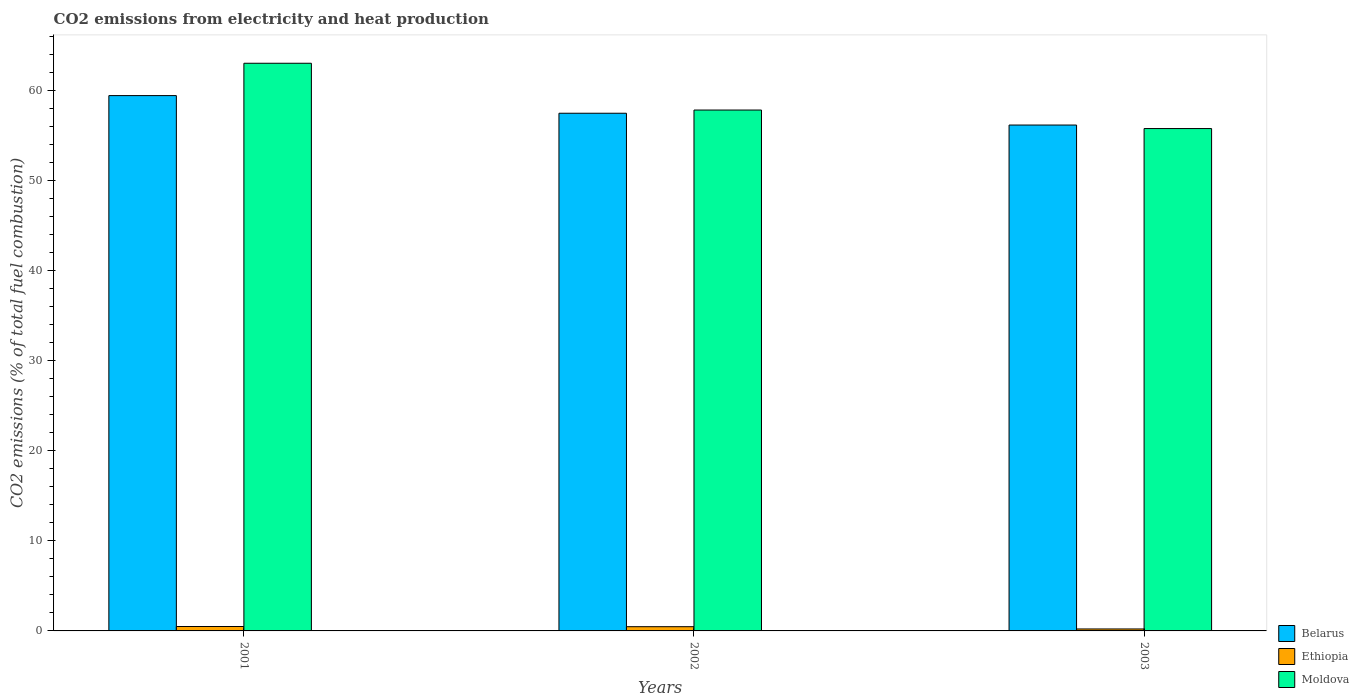How many different coloured bars are there?
Your response must be concise. 3. How many groups of bars are there?
Give a very brief answer. 3. Are the number of bars on each tick of the X-axis equal?
Make the answer very short. Yes. How many bars are there on the 2nd tick from the left?
Your answer should be very brief. 3. How many bars are there on the 2nd tick from the right?
Ensure brevity in your answer.  3. What is the label of the 2nd group of bars from the left?
Provide a succinct answer. 2002. In how many cases, is the number of bars for a given year not equal to the number of legend labels?
Keep it short and to the point. 0. What is the amount of CO2 emitted in Ethiopia in 2001?
Keep it short and to the point. 0.49. Across all years, what is the maximum amount of CO2 emitted in Moldova?
Ensure brevity in your answer.  63. Across all years, what is the minimum amount of CO2 emitted in Belarus?
Offer a terse response. 56.14. What is the total amount of CO2 emitted in Belarus in the graph?
Your answer should be very brief. 172.99. What is the difference between the amount of CO2 emitted in Moldova in 2001 and that in 2002?
Give a very brief answer. 5.19. What is the difference between the amount of CO2 emitted in Moldova in 2003 and the amount of CO2 emitted in Ethiopia in 2001?
Ensure brevity in your answer.  55.26. What is the average amount of CO2 emitted in Moldova per year?
Ensure brevity in your answer.  58.85. In the year 2003, what is the difference between the amount of CO2 emitted in Ethiopia and amount of CO2 emitted in Belarus?
Ensure brevity in your answer.  -55.92. In how many years, is the amount of CO2 emitted in Moldova greater than 58 %?
Offer a terse response. 1. What is the ratio of the amount of CO2 emitted in Belarus in 2002 to that in 2003?
Offer a very short reply. 1.02. Is the amount of CO2 emitted in Ethiopia in 2002 less than that in 2003?
Offer a very short reply. No. What is the difference between the highest and the second highest amount of CO2 emitted in Ethiopia?
Provide a succinct answer. 0.02. What is the difference between the highest and the lowest amount of CO2 emitted in Ethiopia?
Offer a very short reply. 0.27. What does the 1st bar from the left in 2002 represents?
Your answer should be compact. Belarus. What does the 3rd bar from the right in 2002 represents?
Provide a succinct answer. Belarus. Is it the case that in every year, the sum of the amount of CO2 emitted in Moldova and amount of CO2 emitted in Ethiopia is greater than the amount of CO2 emitted in Belarus?
Ensure brevity in your answer.  No. Are all the bars in the graph horizontal?
Provide a succinct answer. No. Are the values on the major ticks of Y-axis written in scientific E-notation?
Keep it short and to the point. No. Does the graph contain grids?
Keep it short and to the point. No. How are the legend labels stacked?
Make the answer very short. Vertical. What is the title of the graph?
Give a very brief answer. CO2 emissions from electricity and heat production. Does "Moldova" appear as one of the legend labels in the graph?
Offer a very short reply. Yes. What is the label or title of the Y-axis?
Your answer should be compact. CO2 emissions (% of total fuel combustion). What is the CO2 emissions (% of total fuel combustion) of Belarus in 2001?
Your answer should be compact. 59.41. What is the CO2 emissions (% of total fuel combustion) in Ethiopia in 2001?
Ensure brevity in your answer.  0.49. What is the CO2 emissions (% of total fuel combustion) of Moldova in 2001?
Make the answer very short. 63. What is the CO2 emissions (% of total fuel combustion) in Belarus in 2002?
Offer a terse response. 57.45. What is the CO2 emissions (% of total fuel combustion) in Ethiopia in 2002?
Offer a very short reply. 0.47. What is the CO2 emissions (% of total fuel combustion) in Moldova in 2002?
Your response must be concise. 57.8. What is the CO2 emissions (% of total fuel combustion) in Belarus in 2003?
Your answer should be compact. 56.14. What is the CO2 emissions (% of total fuel combustion) of Ethiopia in 2003?
Offer a very short reply. 0.22. What is the CO2 emissions (% of total fuel combustion) of Moldova in 2003?
Give a very brief answer. 55.75. Across all years, what is the maximum CO2 emissions (% of total fuel combustion) of Belarus?
Provide a short and direct response. 59.41. Across all years, what is the maximum CO2 emissions (% of total fuel combustion) of Ethiopia?
Offer a very short reply. 0.49. Across all years, what is the maximum CO2 emissions (% of total fuel combustion) in Moldova?
Keep it short and to the point. 63. Across all years, what is the minimum CO2 emissions (% of total fuel combustion) of Belarus?
Give a very brief answer. 56.14. Across all years, what is the minimum CO2 emissions (% of total fuel combustion) of Ethiopia?
Keep it short and to the point. 0.22. Across all years, what is the minimum CO2 emissions (% of total fuel combustion) of Moldova?
Keep it short and to the point. 55.75. What is the total CO2 emissions (% of total fuel combustion) of Belarus in the graph?
Provide a short and direct response. 172.99. What is the total CO2 emissions (% of total fuel combustion) of Ethiopia in the graph?
Offer a terse response. 1.18. What is the total CO2 emissions (% of total fuel combustion) in Moldova in the graph?
Your answer should be compact. 176.55. What is the difference between the CO2 emissions (% of total fuel combustion) of Belarus in 2001 and that in 2002?
Provide a succinct answer. 1.96. What is the difference between the CO2 emissions (% of total fuel combustion) in Ethiopia in 2001 and that in 2002?
Keep it short and to the point. 0.02. What is the difference between the CO2 emissions (% of total fuel combustion) of Moldova in 2001 and that in 2002?
Provide a short and direct response. 5.19. What is the difference between the CO2 emissions (% of total fuel combustion) in Belarus in 2001 and that in 2003?
Provide a succinct answer. 3.27. What is the difference between the CO2 emissions (% of total fuel combustion) in Ethiopia in 2001 and that in 2003?
Your answer should be very brief. 0.27. What is the difference between the CO2 emissions (% of total fuel combustion) of Moldova in 2001 and that in 2003?
Your answer should be compact. 7.25. What is the difference between the CO2 emissions (% of total fuel combustion) of Belarus in 2002 and that in 2003?
Your response must be concise. 1.31. What is the difference between the CO2 emissions (% of total fuel combustion) of Ethiopia in 2002 and that in 2003?
Give a very brief answer. 0.25. What is the difference between the CO2 emissions (% of total fuel combustion) of Moldova in 2002 and that in 2003?
Your answer should be very brief. 2.05. What is the difference between the CO2 emissions (% of total fuel combustion) in Belarus in 2001 and the CO2 emissions (% of total fuel combustion) in Ethiopia in 2002?
Your answer should be very brief. 58.94. What is the difference between the CO2 emissions (% of total fuel combustion) in Belarus in 2001 and the CO2 emissions (% of total fuel combustion) in Moldova in 2002?
Ensure brevity in your answer.  1.6. What is the difference between the CO2 emissions (% of total fuel combustion) of Ethiopia in 2001 and the CO2 emissions (% of total fuel combustion) of Moldova in 2002?
Offer a terse response. -57.31. What is the difference between the CO2 emissions (% of total fuel combustion) in Belarus in 2001 and the CO2 emissions (% of total fuel combustion) in Ethiopia in 2003?
Give a very brief answer. 59.19. What is the difference between the CO2 emissions (% of total fuel combustion) of Belarus in 2001 and the CO2 emissions (% of total fuel combustion) of Moldova in 2003?
Offer a very short reply. 3.66. What is the difference between the CO2 emissions (% of total fuel combustion) in Ethiopia in 2001 and the CO2 emissions (% of total fuel combustion) in Moldova in 2003?
Your response must be concise. -55.26. What is the difference between the CO2 emissions (% of total fuel combustion) of Belarus in 2002 and the CO2 emissions (% of total fuel combustion) of Ethiopia in 2003?
Your answer should be very brief. 57.23. What is the difference between the CO2 emissions (% of total fuel combustion) of Belarus in 2002 and the CO2 emissions (% of total fuel combustion) of Moldova in 2003?
Make the answer very short. 1.7. What is the difference between the CO2 emissions (% of total fuel combustion) of Ethiopia in 2002 and the CO2 emissions (% of total fuel combustion) of Moldova in 2003?
Your answer should be very brief. -55.28. What is the average CO2 emissions (% of total fuel combustion) of Belarus per year?
Provide a succinct answer. 57.66. What is the average CO2 emissions (% of total fuel combustion) in Ethiopia per year?
Your answer should be very brief. 0.39. What is the average CO2 emissions (% of total fuel combustion) in Moldova per year?
Your answer should be compact. 58.85. In the year 2001, what is the difference between the CO2 emissions (% of total fuel combustion) in Belarus and CO2 emissions (% of total fuel combustion) in Ethiopia?
Your answer should be compact. 58.92. In the year 2001, what is the difference between the CO2 emissions (% of total fuel combustion) in Belarus and CO2 emissions (% of total fuel combustion) in Moldova?
Your answer should be compact. -3.59. In the year 2001, what is the difference between the CO2 emissions (% of total fuel combustion) in Ethiopia and CO2 emissions (% of total fuel combustion) in Moldova?
Your response must be concise. -62.51. In the year 2002, what is the difference between the CO2 emissions (% of total fuel combustion) of Belarus and CO2 emissions (% of total fuel combustion) of Ethiopia?
Keep it short and to the point. 56.98. In the year 2002, what is the difference between the CO2 emissions (% of total fuel combustion) in Belarus and CO2 emissions (% of total fuel combustion) in Moldova?
Provide a succinct answer. -0.36. In the year 2002, what is the difference between the CO2 emissions (% of total fuel combustion) of Ethiopia and CO2 emissions (% of total fuel combustion) of Moldova?
Keep it short and to the point. -57.33. In the year 2003, what is the difference between the CO2 emissions (% of total fuel combustion) of Belarus and CO2 emissions (% of total fuel combustion) of Ethiopia?
Offer a very short reply. 55.92. In the year 2003, what is the difference between the CO2 emissions (% of total fuel combustion) of Belarus and CO2 emissions (% of total fuel combustion) of Moldova?
Your answer should be compact. 0.39. In the year 2003, what is the difference between the CO2 emissions (% of total fuel combustion) of Ethiopia and CO2 emissions (% of total fuel combustion) of Moldova?
Make the answer very short. -55.53. What is the ratio of the CO2 emissions (% of total fuel combustion) of Belarus in 2001 to that in 2002?
Offer a terse response. 1.03. What is the ratio of the CO2 emissions (% of total fuel combustion) in Ethiopia in 2001 to that in 2002?
Keep it short and to the point. 1.04. What is the ratio of the CO2 emissions (% of total fuel combustion) of Moldova in 2001 to that in 2002?
Ensure brevity in your answer.  1.09. What is the ratio of the CO2 emissions (% of total fuel combustion) in Belarus in 2001 to that in 2003?
Offer a very short reply. 1.06. What is the ratio of the CO2 emissions (% of total fuel combustion) of Ethiopia in 2001 to that in 2003?
Give a very brief answer. 2.25. What is the ratio of the CO2 emissions (% of total fuel combustion) in Moldova in 2001 to that in 2003?
Keep it short and to the point. 1.13. What is the ratio of the CO2 emissions (% of total fuel combustion) in Belarus in 2002 to that in 2003?
Provide a succinct answer. 1.02. What is the ratio of the CO2 emissions (% of total fuel combustion) in Ethiopia in 2002 to that in 2003?
Keep it short and to the point. 2.16. What is the ratio of the CO2 emissions (% of total fuel combustion) in Moldova in 2002 to that in 2003?
Ensure brevity in your answer.  1.04. What is the difference between the highest and the second highest CO2 emissions (% of total fuel combustion) in Belarus?
Ensure brevity in your answer.  1.96. What is the difference between the highest and the second highest CO2 emissions (% of total fuel combustion) in Ethiopia?
Provide a succinct answer. 0.02. What is the difference between the highest and the second highest CO2 emissions (% of total fuel combustion) of Moldova?
Give a very brief answer. 5.19. What is the difference between the highest and the lowest CO2 emissions (% of total fuel combustion) in Belarus?
Your answer should be compact. 3.27. What is the difference between the highest and the lowest CO2 emissions (% of total fuel combustion) in Ethiopia?
Provide a succinct answer. 0.27. What is the difference between the highest and the lowest CO2 emissions (% of total fuel combustion) in Moldova?
Provide a short and direct response. 7.25. 